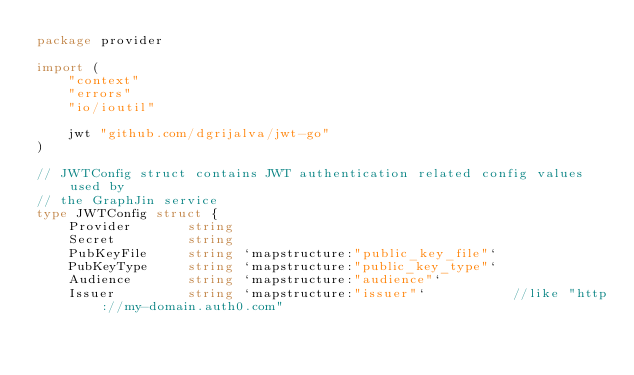Convert code to text. <code><loc_0><loc_0><loc_500><loc_500><_Go_>package provider

import (
	"context"
	"errors"
	"io/ioutil"

	jwt "github.com/dgrijalva/jwt-go"
)

// JWTConfig struct contains JWT authentication related config values used by
// the GraphJin service
type JWTConfig struct {
	Provider       string
	Secret         string
	PubKeyFile     string `mapstructure:"public_key_file"`
	PubKeyType     string `mapstructure:"public_key_type"`
	Audience       string `mapstructure:"audience"`
	Issuer         string `mapstructure:"issuer"`           //like "http://my-domain.auth0.com"</code> 